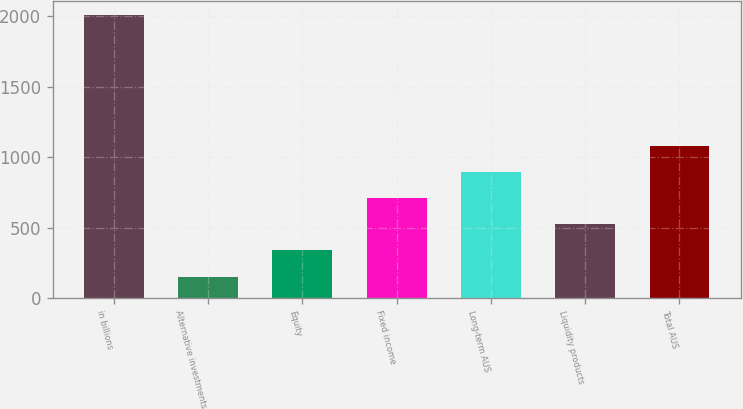Convert chart. <chart><loc_0><loc_0><loc_500><loc_500><bar_chart><fcel>in billions<fcel>Alternative investments<fcel>Equity<fcel>Fixed income<fcel>Long-term AUS<fcel>Liquidity products<fcel>Total AUS<nl><fcel>2011<fcel>152<fcel>337.9<fcel>709.7<fcel>895.6<fcel>523.8<fcel>1081.5<nl></chart> 